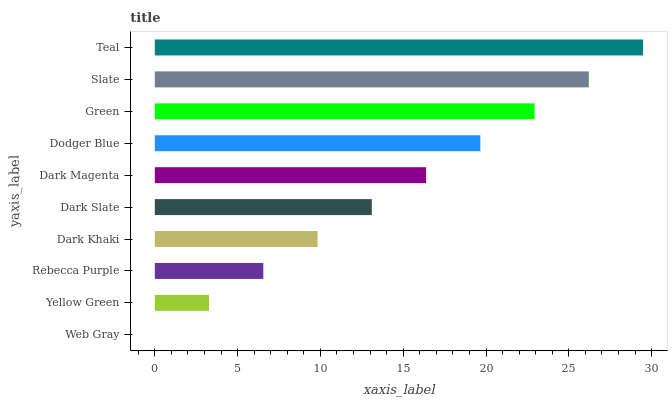Is Web Gray the minimum?
Answer yes or no. Yes. Is Teal the maximum?
Answer yes or no. Yes. Is Yellow Green the minimum?
Answer yes or no. No. Is Yellow Green the maximum?
Answer yes or no. No. Is Yellow Green greater than Web Gray?
Answer yes or no. Yes. Is Web Gray less than Yellow Green?
Answer yes or no. Yes. Is Web Gray greater than Yellow Green?
Answer yes or no. No. Is Yellow Green less than Web Gray?
Answer yes or no. No. Is Dark Magenta the high median?
Answer yes or no. Yes. Is Dark Slate the low median?
Answer yes or no. Yes. Is Rebecca Purple the high median?
Answer yes or no. No. Is Web Gray the low median?
Answer yes or no. No. 